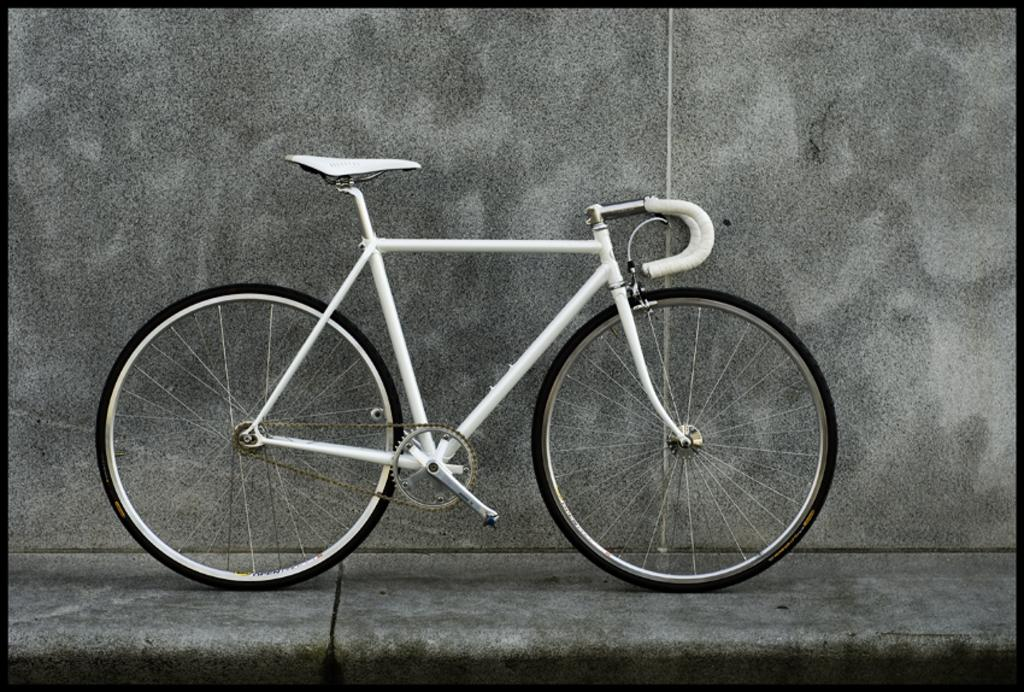What is the main object in the image? There is a bicycle in the image. Where is the bicycle located? The bicycle is on a footpath. What can be seen in the background of the image? There is a well in the background of the image. What type of bun is being used to create shade for the bicycle in the image? There is no bun present in the image; it features a bicycle on a footpath with a well in the background. 